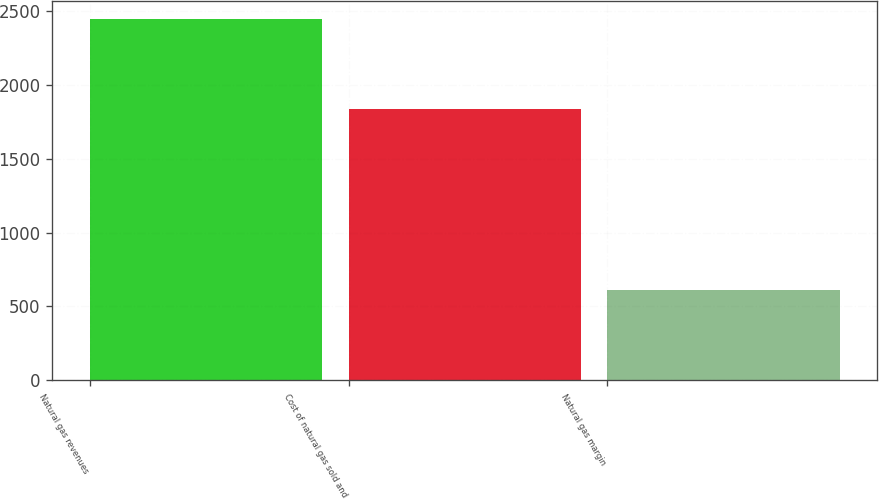<chart> <loc_0><loc_0><loc_500><loc_500><bar_chart><fcel>Natural gas revenues<fcel>Cost of natural gas sold and<fcel>Natural gas margin<nl><fcel>2443<fcel>1833<fcel>610<nl></chart> 